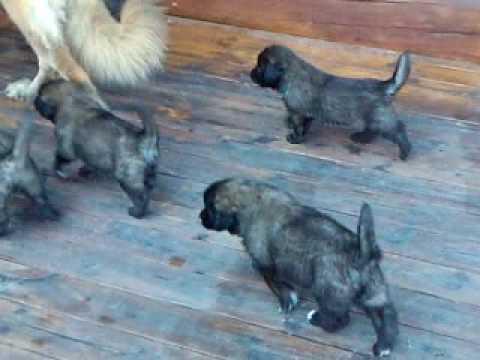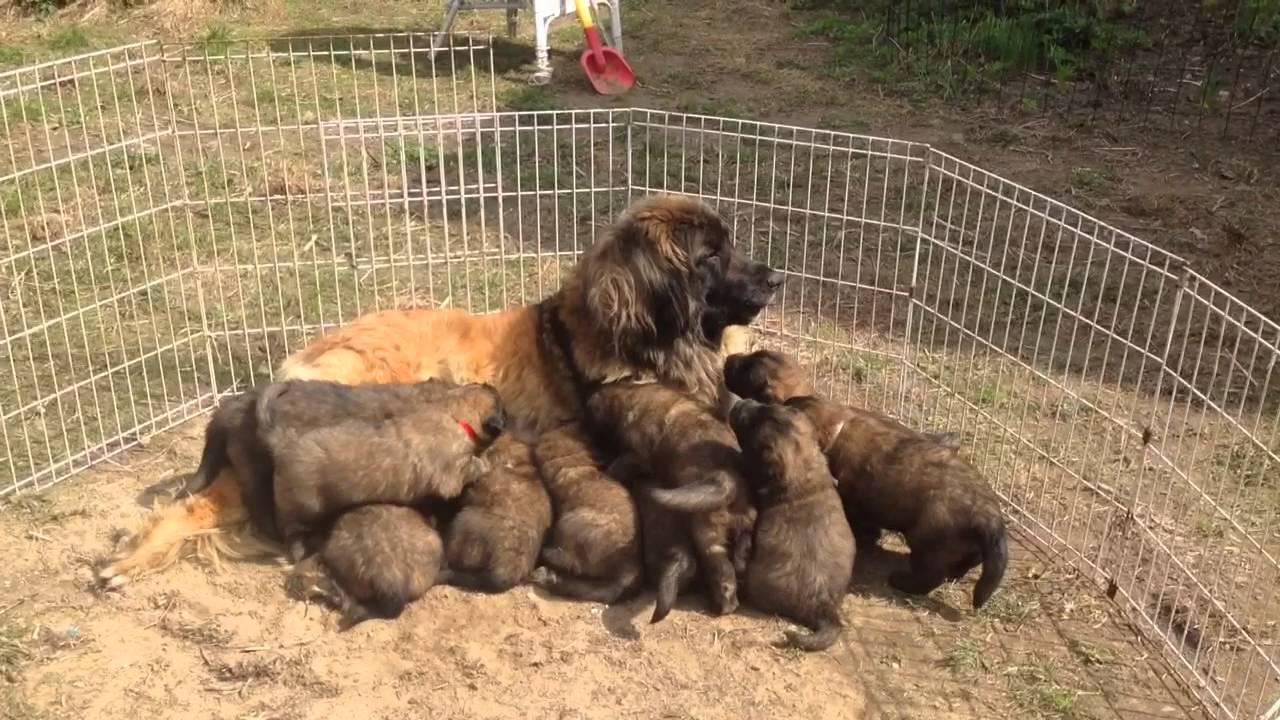The first image is the image on the left, the second image is the image on the right. Given the left and right images, does the statement "An image shows at least one puppy on a stone-type floor with a pattern that includes square shapes." hold true? Answer yes or no. No. The first image is the image on the left, the second image is the image on the right. Analyze the images presented: Is the assertion "A single dog is standing on a white surface in one of the images." valid? Answer yes or no. No. 